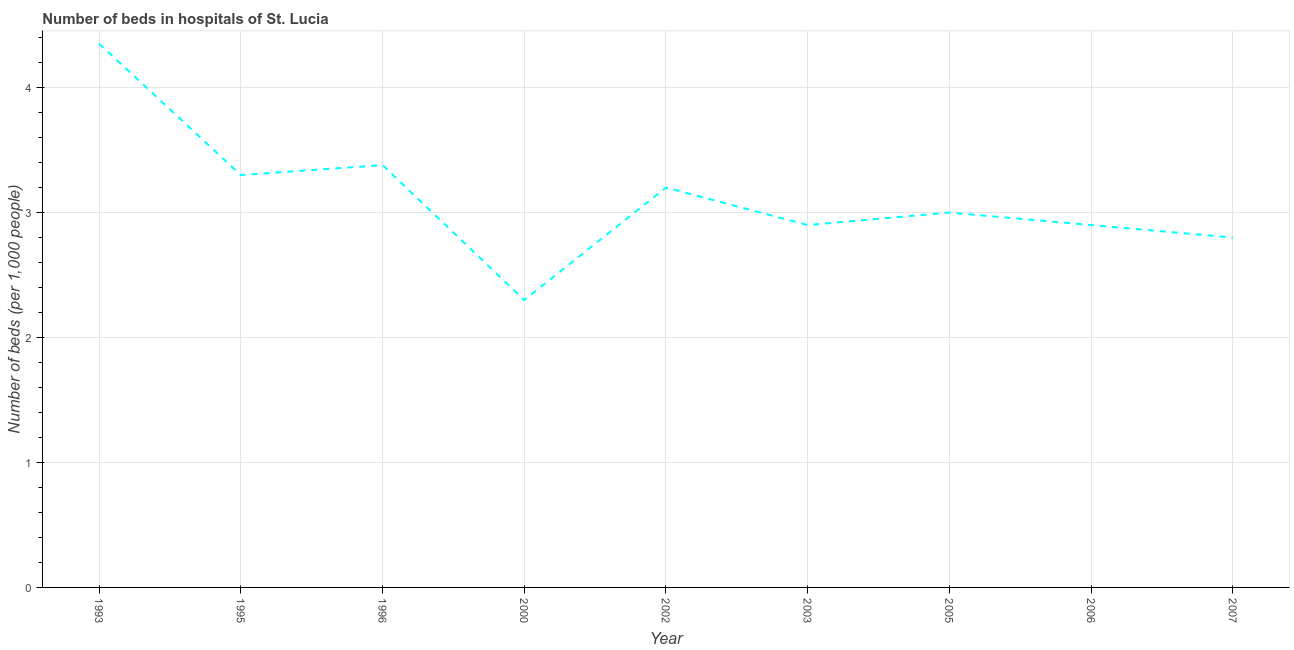What is the number of hospital beds in 2000?
Give a very brief answer. 2.3. Across all years, what is the maximum number of hospital beds?
Keep it short and to the point. 4.35. In which year was the number of hospital beds maximum?
Ensure brevity in your answer.  1993. In which year was the number of hospital beds minimum?
Offer a very short reply. 2000. What is the sum of the number of hospital beds?
Provide a succinct answer. 28.13. What is the difference between the number of hospital beds in 1995 and 2005?
Provide a succinct answer. 0.3. What is the average number of hospital beds per year?
Your answer should be very brief. 3.13. What is the median number of hospital beds?
Your answer should be compact. 3. In how many years, is the number of hospital beds greater than 3 %?
Make the answer very short. 4. What is the ratio of the number of hospital beds in 1995 to that in 2005?
Your answer should be compact. 1.1. Is the number of hospital beds in 2000 less than that in 2006?
Offer a very short reply. Yes. Is the difference between the number of hospital beds in 1995 and 2002 greater than the difference between any two years?
Offer a terse response. No. What is the difference between the highest and the second highest number of hospital beds?
Provide a short and direct response. 0.97. What is the difference between the highest and the lowest number of hospital beds?
Your answer should be compact. 2.05. In how many years, is the number of hospital beds greater than the average number of hospital beds taken over all years?
Keep it short and to the point. 4. Does the number of hospital beds monotonically increase over the years?
Provide a short and direct response. No. How many years are there in the graph?
Make the answer very short. 9. Are the values on the major ticks of Y-axis written in scientific E-notation?
Offer a very short reply. No. What is the title of the graph?
Provide a short and direct response. Number of beds in hospitals of St. Lucia. What is the label or title of the Y-axis?
Provide a succinct answer. Number of beds (per 1,0 people). What is the Number of beds (per 1,000 people) of 1993?
Provide a short and direct response. 4.35. What is the Number of beds (per 1,000 people) in 1995?
Give a very brief answer. 3.3. What is the Number of beds (per 1,000 people) of 1996?
Make the answer very short. 3.38. What is the Number of beds (per 1,000 people) of 2000?
Your answer should be very brief. 2.3. What is the Number of beds (per 1,000 people) in 2002?
Give a very brief answer. 3.2. What is the Number of beds (per 1,000 people) of 2003?
Offer a very short reply. 2.9. What is the Number of beds (per 1,000 people) in 2006?
Give a very brief answer. 2.9. What is the difference between the Number of beds (per 1,000 people) in 1993 and 1995?
Your answer should be very brief. 1.05. What is the difference between the Number of beds (per 1,000 people) in 1993 and 1996?
Ensure brevity in your answer.  0.97. What is the difference between the Number of beds (per 1,000 people) in 1993 and 2000?
Give a very brief answer. 2.05. What is the difference between the Number of beds (per 1,000 people) in 1993 and 2002?
Offer a terse response. 1.15. What is the difference between the Number of beds (per 1,000 people) in 1993 and 2003?
Keep it short and to the point. 1.45. What is the difference between the Number of beds (per 1,000 people) in 1993 and 2005?
Give a very brief answer. 1.35. What is the difference between the Number of beds (per 1,000 people) in 1993 and 2006?
Keep it short and to the point. 1.45. What is the difference between the Number of beds (per 1,000 people) in 1993 and 2007?
Give a very brief answer. 1.55. What is the difference between the Number of beds (per 1,000 people) in 1995 and 1996?
Ensure brevity in your answer.  -0.08. What is the difference between the Number of beds (per 1,000 people) in 1995 and 2000?
Offer a very short reply. 1. What is the difference between the Number of beds (per 1,000 people) in 1995 and 2003?
Offer a terse response. 0.4. What is the difference between the Number of beds (per 1,000 people) in 1995 and 2006?
Your answer should be compact. 0.4. What is the difference between the Number of beds (per 1,000 people) in 1995 and 2007?
Ensure brevity in your answer.  0.5. What is the difference between the Number of beds (per 1,000 people) in 1996 and 2000?
Offer a terse response. 1.08. What is the difference between the Number of beds (per 1,000 people) in 1996 and 2002?
Your answer should be compact. 0.18. What is the difference between the Number of beds (per 1,000 people) in 1996 and 2003?
Your response must be concise. 0.48. What is the difference between the Number of beds (per 1,000 people) in 1996 and 2005?
Provide a succinct answer. 0.38. What is the difference between the Number of beds (per 1,000 people) in 1996 and 2006?
Provide a succinct answer. 0.48. What is the difference between the Number of beds (per 1,000 people) in 1996 and 2007?
Your answer should be compact. 0.58. What is the difference between the Number of beds (per 1,000 people) in 2000 and 2002?
Keep it short and to the point. -0.9. What is the difference between the Number of beds (per 1,000 people) in 2000 and 2007?
Your answer should be very brief. -0.5. What is the difference between the Number of beds (per 1,000 people) in 2003 and 2005?
Your answer should be very brief. -0.1. What is the difference between the Number of beds (per 1,000 people) in 2003 and 2007?
Ensure brevity in your answer.  0.1. What is the difference between the Number of beds (per 1,000 people) in 2005 and 2007?
Your answer should be very brief. 0.2. What is the ratio of the Number of beds (per 1,000 people) in 1993 to that in 1995?
Offer a terse response. 1.32. What is the ratio of the Number of beds (per 1,000 people) in 1993 to that in 1996?
Provide a short and direct response. 1.29. What is the ratio of the Number of beds (per 1,000 people) in 1993 to that in 2000?
Give a very brief answer. 1.89. What is the ratio of the Number of beds (per 1,000 people) in 1993 to that in 2002?
Ensure brevity in your answer.  1.36. What is the ratio of the Number of beds (per 1,000 people) in 1993 to that in 2003?
Give a very brief answer. 1.5. What is the ratio of the Number of beds (per 1,000 people) in 1993 to that in 2005?
Give a very brief answer. 1.45. What is the ratio of the Number of beds (per 1,000 people) in 1993 to that in 2006?
Provide a short and direct response. 1.5. What is the ratio of the Number of beds (per 1,000 people) in 1993 to that in 2007?
Ensure brevity in your answer.  1.55. What is the ratio of the Number of beds (per 1,000 people) in 1995 to that in 1996?
Your response must be concise. 0.98. What is the ratio of the Number of beds (per 1,000 people) in 1995 to that in 2000?
Keep it short and to the point. 1.44. What is the ratio of the Number of beds (per 1,000 people) in 1995 to that in 2002?
Ensure brevity in your answer.  1.03. What is the ratio of the Number of beds (per 1,000 people) in 1995 to that in 2003?
Your answer should be very brief. 1.14. What is the ratio of the Number of beds (per 1,000 people) in 1995 to that in 2006?
Give a very brief answer. 1.14. What is the ratio of the Number of beds (per 1,000 people) in 1995 to that in 2007?
Offer a terse response. 1.18. What is the ratio of the Number of beds (per 1,000 people) in 1996 to that in 2000?
Ensure brevity in your answer.  1.47. What is the ratio of the Number of beds (per 1,000 people) in 1996 to that in 2002?
Ensure brevity in your answer.  1.06. What is the ratio of the Number of beds (per 1,000 people) in 1996 to that in 2003?
Provide a short and direct response. 1.17. What is the ratio of the Number of beds (per 1,000 people) in 1996 to that in 2005?
Your answer should be compact. 1.13. What is the ratio of the Number of beds (per 1,000 people) in 1996 to that in 2006?
Make the answer very short. 1.17. What is the ratio of the Number of beds (per 1,000 people) in 1996 to that in 2007?
Your answer should be very brief. 1.21. What is the ratio of the Number of beds (per 1,000 people) in 2000 to that in 2002?
Offer a terse response. 0.72. What is the ratio of the Number of beds (per 1,000 people) in 2000 to that in 2003?
Provide a short and direct response. 0.79. What is the ratio of the Number of beds (per 1,000 people) in 2000 to that in 2005?
Keep it short and to the point. 0.77. What is the ratio of the Number of beds (per 1,000 people) in 2000 to that in 2006?
Ensure brevity in your answer.  0.79. What is the ratio of the Number of beds (per 1,000 people) in 2000 to that in 2007?
Your answer should be compact. 0.82. What is the ratio of the Number of beds (per 1,000 people) in 2002 to that in 2003?
Make the answer very short. 1.1. What is the ratio of the Number of beds (per 1,000 people) in 2002 to that in 2005?
Your response must be concise. 1.07. What is the ratio of the Number of beds (per 1,000 people) in 2002 to that in 2006?
Offer a very short reply. 1.1. What is the ratio of the Number of beds (per 1,000 people) in 2002 to that in 2007?
Offer a terse response. 1.14. What is the ratio of the Number of beds (per 1,000 people) in 2003 to that in 2005?
Your answer should be compact. 0.97. What is the ratio of the Number of beds (per 1,000 people) in 2003 to that in 2006?
Keep it short and to the point. 1. What is the ratio of the Number of beds (per 1,000 people) in 2003 to that in 2007?
Give a very brief answer. 1.04. What is the ratio of the Number of beds (per 1,000 people) in 2005 to that in 2006?
Offer a terse response. 1.03. What is the ratio of the Number of beds (per 1,000 people) in 2005 to that in 2007?
Give a very brief answer. 1.07. What is the ratio of the Number of beds (per 1,000 people) in 2006 to that in 2007?
Ensure brevity in your answer.  1.04. 